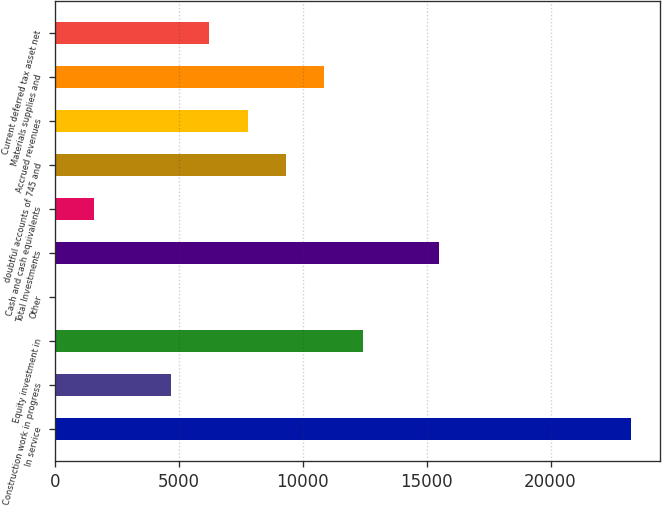<chart> <loc_0><loc_0><loc_500><loc_500><bar_chart><fcel>In service<fcel>Construction work in progress<fcel>Equity investment in<fcel>Other<fcel>Total Investments<fcel>Cash and cash equivalents<fcel>doubtful accounts of 745 and<fcel>Accrued revenues<fcel>Materials supplies and<fcel>Current deferred tax asset net<nl><fcel>23247.1<fcel>4675.66<fcel>12413.8<fcel>32.8<fcel>15509<fcel>1580.42<fcel>9318.52<fcel>7770.9<fcel>10866.1<fcel>6223.28<nl></chart> 